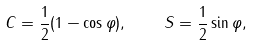Convert formula to latex. <formula><loc_0><loc_0><loc_500><loc_500>C = \frac { 1 } { 2 } ( 1 - \cos \varphi ) , \quad S = \frac { 1 } { 2 } \sin \varphi ,</formula> 